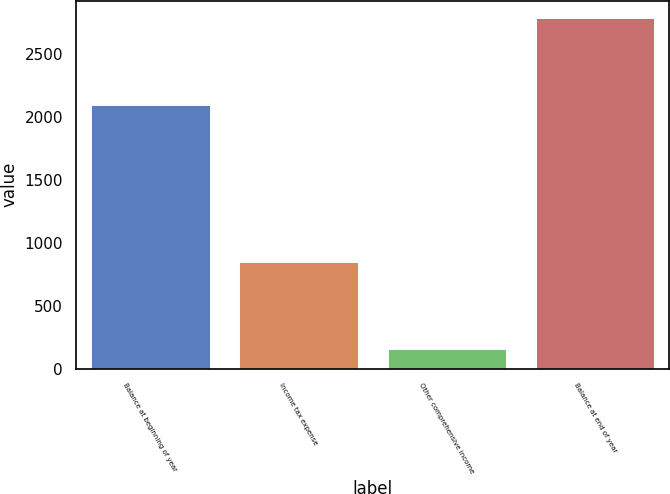Convert chart to OTSL. <chart><loc_0><loc_0><loc_500><loc_500><bar_chart><fcel>Balance at beginning of year<fcel>Income tax expense<fcel>Other comprehensive income<fcel>Balance at end of year<nl><fcel>2095<fcel>848<fcel>154<fcel>2789<nl></chart> 